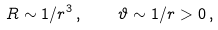Convert formula to latex. <formula><loc_0><loc_0><loc_500><loc_500>R \sim 1 / r ^ { 3 } \, , \quad \vartheta \sim 1 / r > 0 \, ,</formula> 